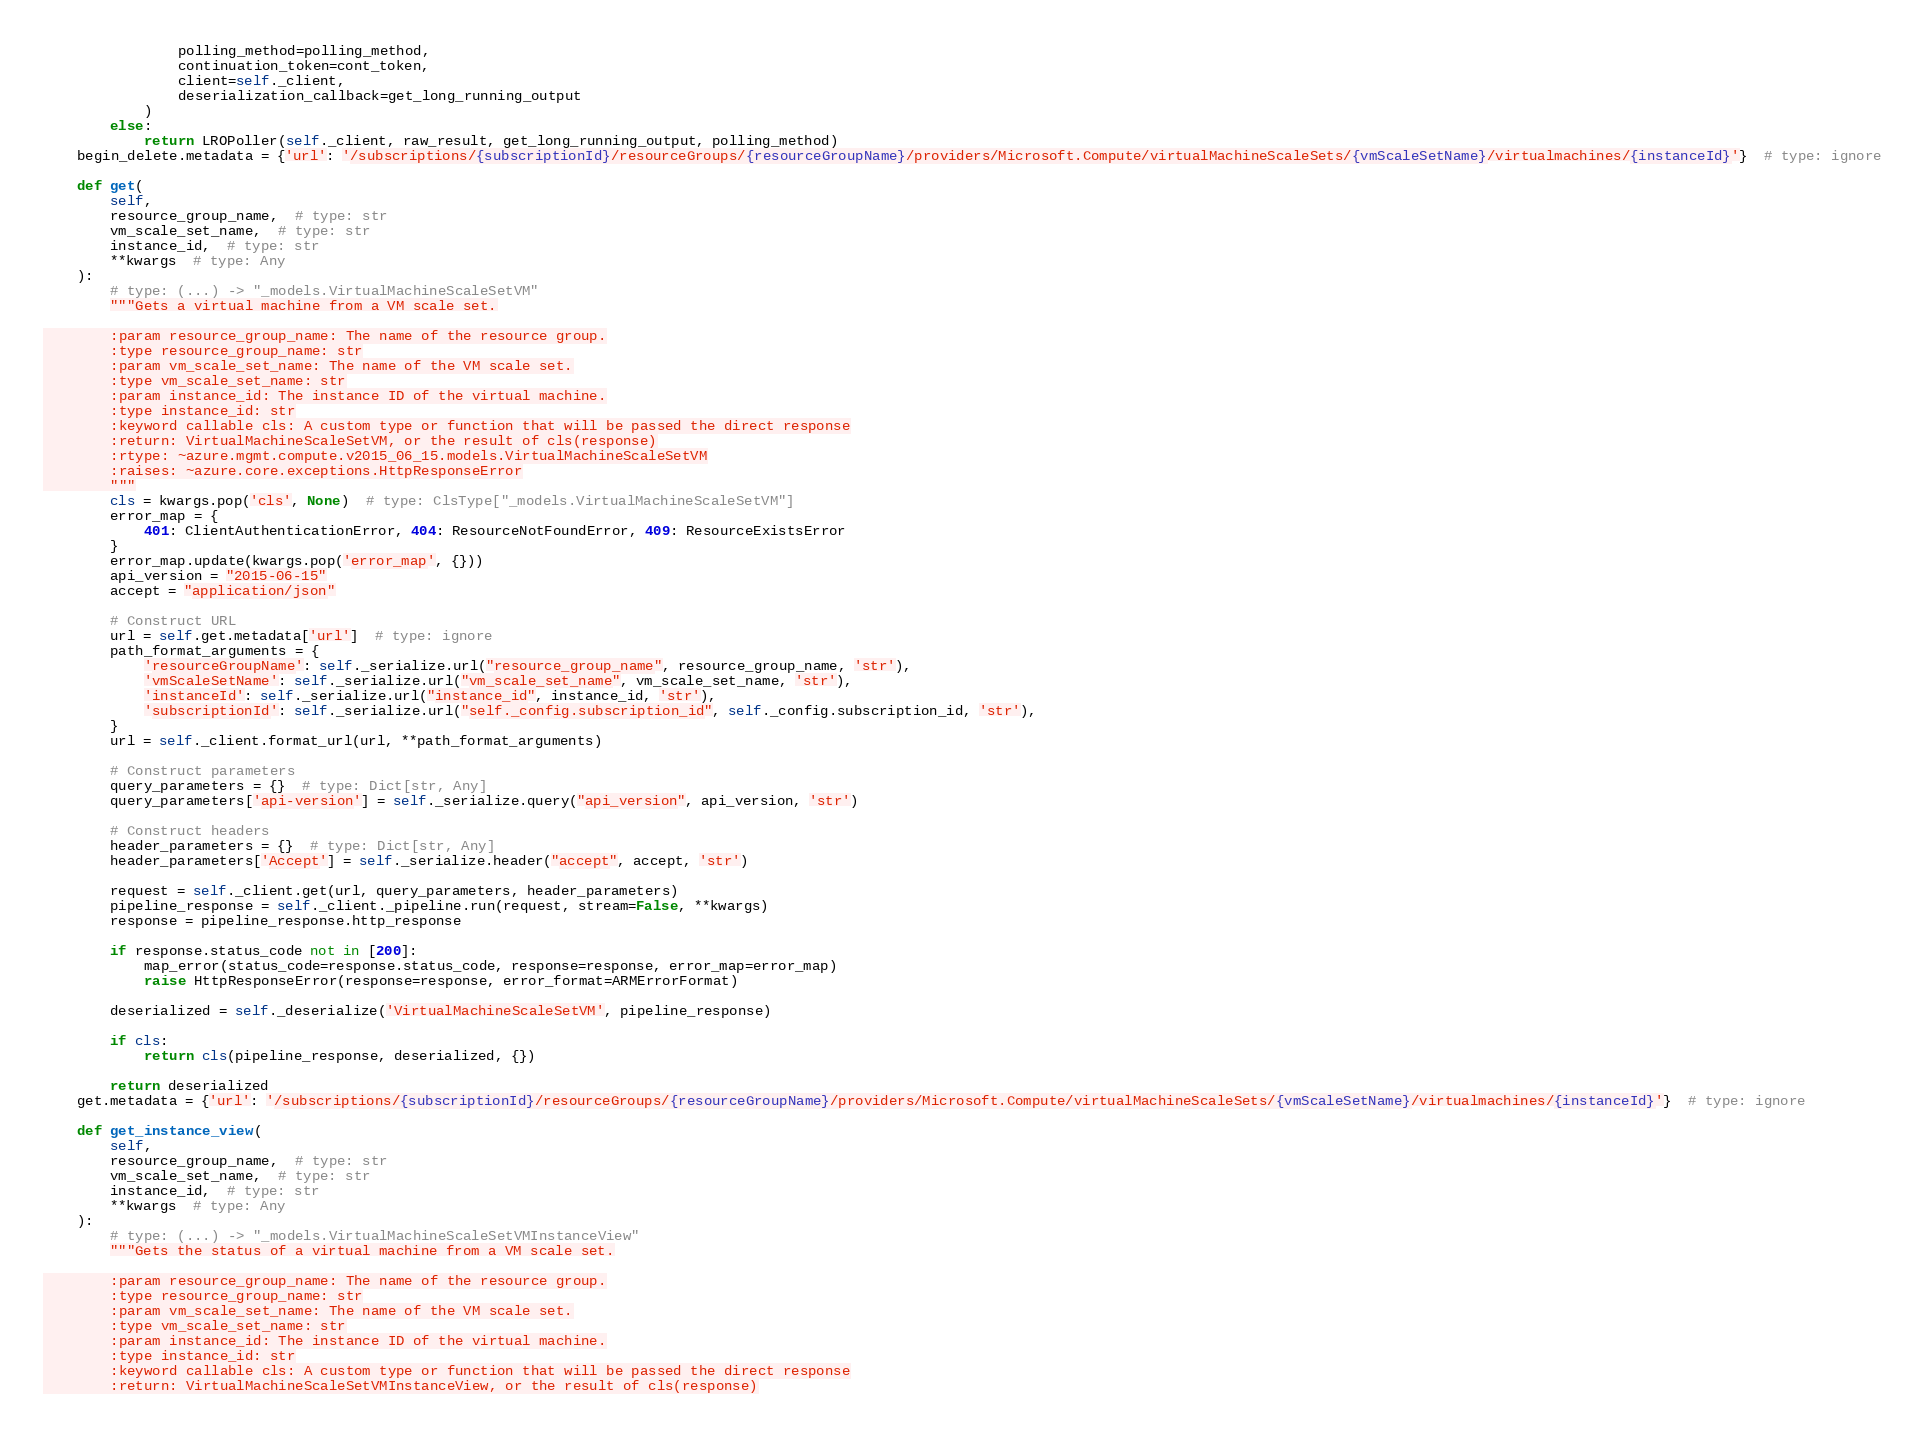<code> <loc_0><loc_0><loc_500><loc_500><_Python_>                polling_method=polling_method,
                continuation_token=cont_token,
                client=self._client,
                deserialization_callback=get_long_running_output
            )
        else:
            return LROPoller(self._client, raw_result, get_long_running_output, polling_method)
    begin_delete.metadata = {'url': '/subscriptions/{subscriptionId}/resourceGroups/{resourceGroupName}/providers/Microsoft.Compute/virtualMachineScaleSets/{vmScaleSetName}/virtualmachines/{instanceId}'}  # type: ignore

    def get(
        self,
        resource_group_name,  # type: str
        vm_scale_set_name,  # type: str
        instance_id,  # type: str
        **kwargs  # type: Any
    ):
        # type: (...) -> "_models.VirtualMachineScaleSetVM"
        """Gets a virtual machine from a VM scale set.

        :param resource_group_name: The name of the resource group.
        :type resource_group_name: str
        :param vm_scale_set_name: The name of the VM scale set.
        :type vm_scale_set_name: str
        :param instance_id: The instance ID of the virtual machine.
        :type instance_id: str
        :keyword callable cls: A custom type or function that will be passed the direct response
        :return: VirtualMachineScaleSetVM, or the result of cls(response)
        :rtype: ~azure.mgmt.compute.v2015_06_15.models.VirtualMachineScaleSetVM
        :raises: ~azure.core.exceptions.HttpResponseError
        """
        cls = kwargs.pop('cls', None)  # type: ClsType["_models.VirtualMachineScaleSetVM"]
        error_map = {
            401: ClientAuthenticationError, 404: ResourceNotFoundError, 409: ResourceExistsError
        }
        error_map.update(kwargs.pop('error_map', {}))
        api_version = "2015-06-15"
        accept = "application/json"

        # Construct URL
        url = self.get.metadata['url']  # type: ignore
        path_format_arguments = {
            'resourceGroupName': self._serialize.url("resource_group_name", resource_group_name, 'str'),
            'vmScaleSetName': self._serialize.url("vm_scale_set_name", vm_scale_set_name, 'str'),
            'instanceId': self._serialize.url("instance_id", instance_id, 'str'),
            'subscriptionId': self._serialize.url("self._config.subscription_id", self._config.subscription_id, 'str'),
        }
        url = self._client.format_url(url, **path_format_arguments)

        # Construct parameters
        query_parameters = {}  # type: Dict[str, Any]
        query_parameters['api-version'] = self._serialize.query("api_version", api_version, 'str')

        # Construct headers
        header_parameters = {}  # type: Dict[str, Any]
        header_parameters['Accept'] = self._serialize.header("accept", accept, 'str')

        request = self._client.get(url, query_parameters, header_parameters)
        pipeline_response = self._client._pipeline.run(request, stream=False, **kwargs)
        response = pipeline_response.http_response

        if response.status_code not in [200]:
            map_error(status_code=response.status_code, response=response, error_map=error_map)
            raise HttpResponseError(response=response, error_format=ARMErrorFormat)

        deserialized = self._deserialize('VirtualMachineScaleSetVM', pipeline_response)

        if cls:
            return cls(pipeline_response, deserialized, {})

        return deserialized
    get.metadata = {'url': '/subscriptions/{subscriptionId}/resourceGroups/{resourceGroupName}/providers/Microsoft.Compute/virtualMachineScaleSets/{vmScaleSetName}/virtualmachines/{instanceId}'}  # type: ignore

    def get_instance_view(
        self,
        resource_group_name,  # type: str
        vm_scale_set_name,  # type: str
        instance_id,  # type: str
        **kwargs  # type: Any
    ):
        # type: (...) -> "_models.VirtualMachineScaleSetVMInstanceView"
        """Gets the status of a virtual machine from a VM scale set.

        :param resource_group_name: The name of the resource group.
        :type resource_group_name: str
        :param vm_scale_set_name: The name of the VM scale set.
        :type vm_scale_set_name: str
        :param instance_id: The instance ID of the virtual machine.
        :type instance_id: str
        :keyword callable cls: A custom type or function that will be passed the direct response
        :return: VirtualMachineScaleSetVMInstanceView, or the result of cls(response)</code> 